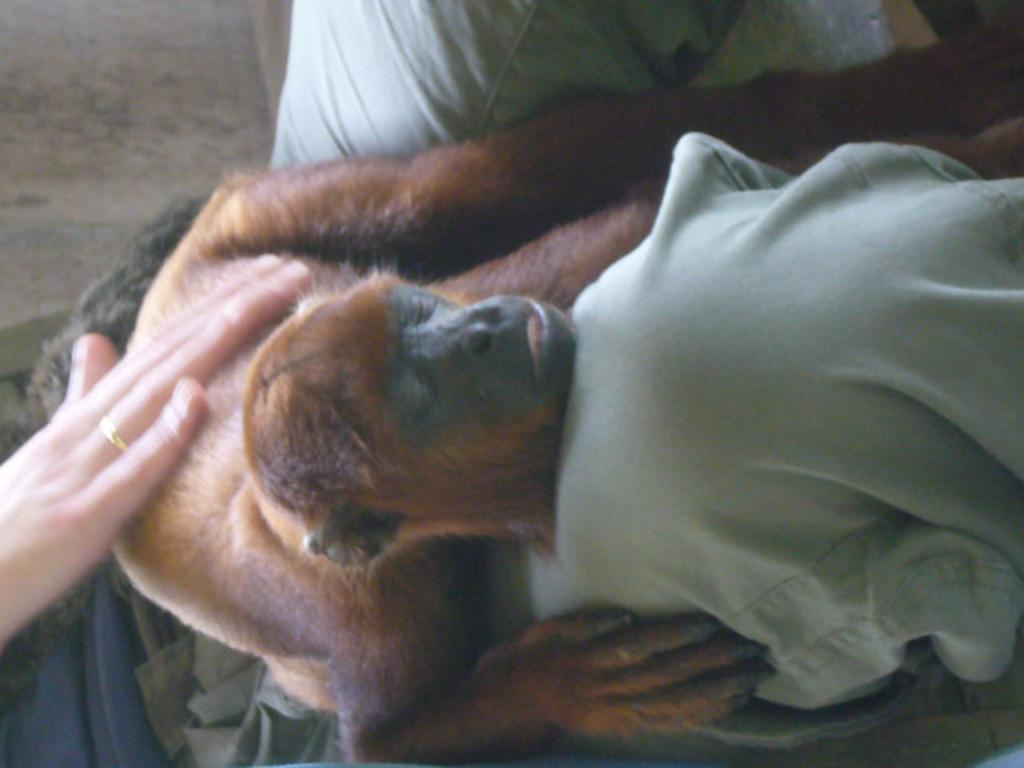What is the main subject in the center of the image? There is a monkey in the center of the image. Can you describe the interaction between the monkey and another subject in the image? A person's hand is on the monkey on the left side of the image. What type of lace is being used to tie the monkey's tail in the image? There is no lace present in the image, nor is the monkey's tail tied with any material. 